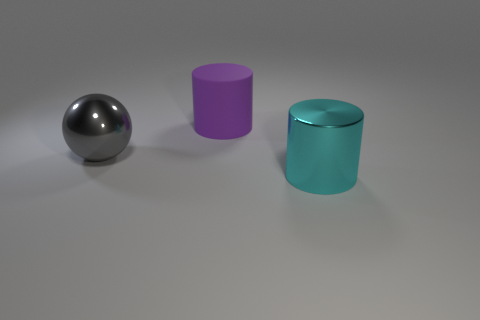Is the thing that is behind the gray shiny ball made of the same material as the thing in front of the large gray thing?
Provide a succinct answer. No. There is another thing that is the same material as the large gray object; what shape is it?
Keep it short and to the point. Cylinder. Are there any other things that are the same color as the sphere?
Provide a succinct answer. No. How many large metallic things are there?
Keep it short and to the point. 2. What is the shape of the big object that is both in front of the matte object and right of the big gray thing?
Offer a terse response. Cylinder. What shape is the large metallic thing to the right of the big cylinder behind the large cylinder that is in front of the matte object?
Ensure brevity in your answer.  Cylinder. What is the thing that is on the right side of the gray sphere and behind the large cyan object made of?
Offer a very short reply. Rubber. What number of rubber cylinders are the same size as the purple matte object?
Offer a terse response. 0. What number of rubber objects are tiny cyan cubes or cyan objects?
Make the answer very short. 0. What material is the large purple cylinder?
Provide a short and direct response. Rubber. 